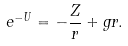<formula> <loc_0><loc_0><loc_500><loc_500>e ^ { - U } = - \frac { Z } { r } + g r .</formula> 